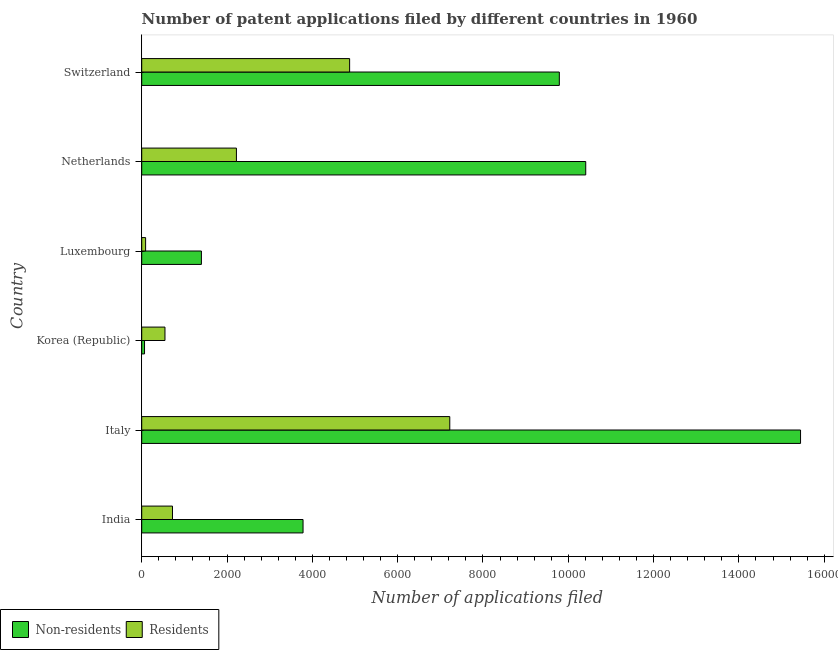Are the number of bars per tick equal to the number of legend labels?
Your answer should be very brief. Yes. How many bars are there on the 6th tick from the top?
Your answer should be compact. 2. What is the label of the 1st group of bars from the top?
Make the answer very short. Switzerland. In how many cases, is the number of bars for a given country not equal to the number of legend labels?
Offer a very short reply. 0. What is the number of patent applications by non residents in Luxembourg?
Your answer should be compact. 1399. Across all countries, what is the maximum number of patent applications by residents?
Keep it short and to the point. 7222. Across all countries, what is the minimum number of patent applications by non residents?
Your response must be concise. 66. What is the total number of patent applications by non residents in the graph?
Your answer should be compact. 4.09e+04. What is the difference between the number of patent applications by residents in Italy and that in Netherlands?
Your answer should be compact. 5002. What is the difference between the number of patent applications by non residents in Netherlands and the number of patent applications by residents in Switzerland?
Ensure brevity in your answer.  5535. What is the average number of patent applications by non residents per country?
Offer a terse response. 6815.17. What is the difference between the number of patent applications by non residents and number of patent applications by residents in Korea (Republic)?
Keep it short and to the point. -479. What is the ratio of the number of patent applications by non residents in Italy to that in Netherlands?
Ensure brevity in your answer.  1.48. What is the difference between the highest and the second highest number of patent applications by residents?
Offer a terse response. 2348. What is the difference between the highest and the lowest number of patent applications by residents?
Keep it short and to the point. 7131. In how many countries, is the number of patent applications by non residents greater than the average number of patent applications by non residents taken over all countries?
Keep it short and to the point. 3. What does the 2nd bar from the top in India represents?
Your answer should be compact. Non-residents. What does the 2nd bar from the bottom in India represents?
Your answer should be compact. Residents. What is the difference between two consecutive major ticks on the X-axis?
Make the answer very short. 2000. Does the graph contain any zero values?
Your answer should be very brief. No. Does the graph contain grids?
Provide a short and direct response. No. How are the legend labels stacked?
Ensure brevity in your answer.  Horizontal. What is the title of the graph?
Ensure brevity in your answer.  Number of patent applications filed by different countries in 1960. Does "Investments" appear as one of the legend labels in the graph?
Provide a short and direct response. No. What is the label or title of the X-axis?
Keep it short and to the point. Number of applications filed. What is the Number of applications filed of Non-residents in India?
Your answer should be very brief. 3782. What is the Number of applications filed in Residents in India?
Offer a very short reply. 721. What is the Number of applications filed of Non-residents in Italy?
Your answer should be compact. 1.54e+04. What is the Number of applications filed in Residents in Italy?
Your answer should be very brief. 7222. What is the Number of applications filed in Non-residents in Korea (Republic)?
Keep it short and to the point. 66. What is the Number of applications filed in Residents in Korea (Republic)?
Provide a short and direct response. 545. What is the Number of applications filed in Non-residents in Luxembourg?
Provide a succinct answer. 1399. What is the Number of applications filed in Residents in Luxembourg?
Keep it short and to the point. 91. What is the Number of applications filed in Non-residents in Netherlands?
Your response must be concise. 1.04e+04. What is the Number of applications filed of Residents in Netherlands?
Provide a short and direct response. 2220. What is the Number of applications filed in Non-residents in Switzerland?
Give a very brief answer. 9790. What is the Number of applications filed of Residents in Switzerland?
Provide a succinct answer. 4874. Across all countries, what is the maximum Number of applications filed in Non-residents?
Offer a terse response. 1.54e+04. Across all countries, what is the maximum Number of applications filed of Residents?
Provide a short and direct response. 7222. Across all countries, what is the minimum Number of applications filed in Residents?
Provide a short and direct response. 91. What is the total Number of applications filed of Non-residents in the graph?
Offer a terse response. 4.09e+04. What is the total Number of applications filed in Residents in the graph?
Provide a succinct answer. 1.57e+04. What is the difference between the Number of applications filed of Non-residents in India and that in Italy?
Offer a terse response. -1.17e+04. What is the difference between the Number of applications filed in Residents in India and that in Italy?
Keep it short and to the point. -6501. What is the difference between the Number of applications filed in Non-residents in India and that in Korea (Republic)?
Offer a very short reply. 3716. What is the difference between the Number of applications filed in Residents in India and that in Korea (Republic)?
Offer a very short reply. 176. What is the difference between the Number of applications filed of Non-residents in India and that in Luxembourg?
Ensure brevity in your answer.  2383. What is the difference between the Number of applications filed of Residents in India and that in Luxembourg?
Make the answer very short. 630. What is the difference between the Number of applications filed of Non-residents in India and that in Netherlands?
Keep it short and to the point. -6627. What is the difference between the Number of applications filed in Residents in India and that in Netherlands?
Provide a succinct answer. -1499. What is the difference between the Number of applications filed in Non-residents in India and that in Switzerland?
Offer a very short reply. -6008. What is the difference between the Number of applications filed in Residents in India and that in Switzerland?
Ensure brevity in your answer.  -4153. What is the difference between the Number of applications filed in Non-residents in Italy and that in Korea (Republic)?
Offer a very short reply. 1.54e+04. What is the difference between the Number of applications filed in Residents in Italy and that in Korea (Republic)?
Provide a short and direct response. 6677. What is the difference between the Number of applications filed in Non-residents in Italy and that in Luxembourg?
Provide a short and direct response. 1.40e+04. What is the difference between the Number of applications filed in Residents in Italy and that in Luxembourg?
Provide a succinct answer. 7131. What is the difference between the Number of applications filed in Non-residents in Italy and that in Netherlands?
Ensure brevity in your answer.  5036. What is the difference between the Number of applications filed in Residents in Italy and that in Netherlands?
Keep it short and to the point. 5002. What is the difference between the Number of applications filed of Non-residents in Italy and that in Switzerland?
Give a very brief answer. 5655. What is the difference between the Number of applications filed of Residents in Italy and that in Switzerland?
Keep it short and to the point. 2348. What is the difference between the Number of applications filed in Non-residents in Korea (Republic) and that in Luxembourg?
Your answer should be compact. -1333. What is the difference between the Number of applications filed in Residents in Korea (Republic) and that in Luxembourg?
Your answer should be compact. 454. What is the difference between the Number of applications filed of Non-residents in Korea (Republic) and that in Netherlands?
Provide a short and direct response. -1.03e+04. What is the difference between the Number of applications filed of Residents in Korea (Republic) and that in Netherlands?
Offer a terse response. -1675. What is the difference between the Number of applications filed in Non-residents in Korea (Republic) and that in Switzerland?
Give a very brief answer. -9724. What is the difference between the Number of applications filed of Residents in Korea (Republic) and that in Switzerland?
Your answer should be very brief. -4329. What is the difference between the Number of applications filed of Non-residents in Luxembourg and that in Netherlands?
Give a very brief answer. -9010. What is the difference between the Number of applications filed in Residents in Luxembourg and that in Netherlands?
Your answer should be very brief. -2129. What is the difference between the Number of applications filed of Non-residents in Luxembourg and that in Switzerland?
Your answer should be compact. -8391. What is the difference between the Number of applications filed of Residents in Luxembourg and that in Switzerland?
Offer a very short reply. -4783. What is the difference between the Number of applications filed in Non-residents in Netherlands and that in Switzerland?
Make the answer very short. 619. What is the difference between the Number of applications filed in Residents in Netherlands and that in Switzerland?
Offer a terse response. -2654. What is the difference between the Number of applications filed of Non-residents in India and the Number of applications filed of Residents in Italy?
Your response must be concise. -3440. What is the difference between the Number of applications filed in Non-residents in India and the Number of applications filed in Residents in Korea (Republic)?
Your answer should be compact. 3237. What is the difference between the Number of applications filed in Non-residents in India and the Number of applications filed in Residents in Luxembourg?
Give a very brief answer. 3691. What is the difference between the Number of applications filed in Non-residents in India and the Number of applications filed in Residents in Netherlands?
Keep it short and to the point. 1562. What is the difference between the Number of applications filed in Non-residents in India and the Number of applications filed in Residents in Switzerland?
Offer a terse response. -1092. What is the difference between the Number of applications filed of Non-residents in Italy and the Number of applications filed of Residents in Korea (Republic)?
Offer a very short reply. 1.49e+04. What is the difference between the Number of applications filed in Non-residents in Italy and the Number of applications filed in Residents in Luxembourg?
Your response must be concise. 1.54e+04. What is the difference between the Number of applications filed of Non-residents in Italy and the Number of applications filed of Residents in Netherlands?
Your answer should be very brief. 1.32e+04. What is the difference between the Number of applications filed in Non-residents in Italy and the Number of applications filed in Residents in Switzerland?
Provide a short and direct response. 1.06e+04. What is the difference between the Number of applications filed in Non-residents in Korea (Republic) and the Number of applications filed in Residents in Luxembourg?
Your answer should be compact. -25. What is the difference between the Number of applications filed of Non-residents in Korea (Republic) and the Number of applications filed of Residents in Netherlands?
Your answer should be very brief. -2154. What is the difference between the Number of applications filed in Non-residents in Korea (Republic) and the Number of applications filed in Residents in Switzerland?
Keep it short and to the point. -4808. What is the difference between the Number of applications filed in Non-residents in Luxembourg and the Number of applications filed in Residents in Netherlands?
Ensure brevity in your answer.  -821. What is the difference between the Number of applications filed of Non-residents in Luxembourg and the Number of applications filed of Residents in Switzerland?
Offer a terse response. -3475. What is the difference between the Number of applications filed of Non-residents in Netherlands and the Number of applications filed of Residents in Switzerland?
Your response must be concise. 5535. What is the average Number of applications filed in Non-residents per country?
Your response must be concise. 6815.17. What is the average Number of applications filed of Residents per country?
Offer a terse response. 2612.17. What is the difference between the Number of applications filed of Non-residents and Number of applications filed of Residents in India?
Give a very brief answer. 3061. What is the difference between the Number of applications filed in Non-residents and Number of applications filed in Residents in Italy?
Make the answer very short. 8223. What is the difference between the Number of applications filed in Non-residents and Number of applications filed in Residents in Korea (Republic)?
Provide a succinct answer. -479. What is the difference between the Number of applications filed in Non-residents and Number of applications filed in Residents in Luxembourg?
Offer a very short reply. 1308. What is the difference between the Number of applications filed in Non-residents and Number of applications filed in Residents in Netherlands?
Keep it short and to the point. 8189. What is the difference between the Number of applications filed in Non-residents and Number of applications filed in Residents in Switzerland?
Your answer should be compact. 4916. What is the ratio of the Number of applications filed of Non-residents in India to that in Italy?
Offer a very short reply. 0.24. What is the ratio of the Number of applications filed in Residents in India to that in Italy?
Provide a succinct answer. 0.1. What is the ratio of the Number of applications filed in Non-residents in India to that in Korea (Republic)?
Provide a succinct answer. 57.3. What is the ratio of the Number of applications filed of Residents in India to that in Korea (Republic)?
Provide a succinct answer. 1.32. What is the ratio of the Number of applications filed in Non-residents in India to that in Luxembourg?
Your response must be concise. 2.7. What is the ratio of the Number of applications filed in Residents in India to that in Luxembourg?
Ensure brevity in your answer.  7.92. What is the ratio of the Number of applications filed in Non-residents in India to that in Netherlands?
Your answer should be compact. 0.36. What is the ratio of the Number of applications filed in Residents in India to that in Netherlands?
Provide a short and direct response. 0.32. What is the ratio of the Number of applications filed in Non-residents in India to that in Switzerland?
Your answer should be compact. 0.39. What is the ratio of the Number of applications filed in Residents in India to that in Switzerland?
Provide a succinct answer. 0.15. What is the ratio of the Number of applications filed of Non-residents in Italy to that in Korea (Republic)?
Ensure brevity in your answer.  234.02. What is the ratio of the Number of applications filed of Residents in Italy to that in Korea (Republic)?
Keep it short and to the point. 13.25. What is the ratio of the Number of applications filed in Non-residents in Italy to that in Luxembourg?
Your response must be concise. 11.04. What is the ratio of the Number of applications filed in Residents in Italy to that in Luxembourg?
Give a very brief answer. 79.36. What is the ratio of the Number of applications filed in Non-residents in Italy to that in Netherlands?
Give a very brief answer. 1.48. What is the ratio of the Number of applications filed in Residents in Italy to that in Netherlands?
Make the answer very short. 3.25. What is the ratio of the Number of applications filed in Non-residents in Italy to that in Switzerland?
Make the answer very short. 1.58. What is the ratio of the Number of applications filed in Residents in Italy to that in Switzerland?
Keep it short and to the point. 1.48. What is the ratio of the Number of applications filed of Non-residents in Korea (Republic) to that in Luxembourg?
Provide a succinct answer. 0.05. What is the ratio of the Number of applications filed in Residents in Korea (Republic) to that in Luxembourg?
Your answer should be compact. 5.99. What is the ratio of the Number of applications filed of Non-residents in Korea (Republic) to that in Netherlands?
Offer a very short reply. 0.01. What is the ratio of the Number of applications filed in Residents in Korea (Republic) to that in Netherlands?
Your answer should be very brief. 0.25. What is the ratio of the Number of applications filed of Non-residents in Korea (Republic) to that in Switzerland?
Keep it short and to the point. 0.01. What is the ratio of the Number of applications filed of Residents in Korea (Republic) to that in Switzerland?
Offer a terse response. 0.11. What is the ratio of the Number of applications filed of Non-residents in Luxembourg to that in Netherlands?
Make the answer very short. 0.13. What is the ratio of the Number of applications filed of Residents in Luxembourg to that in Netherlands?
Offer a very short reply. 0.04. What is the ratio of the Number of applications filed of Non-residents in Luxembourg to that in Switzerland?
Your answer should be very brief. 0.14. What is the ratio of the Number of applications filed in Residents in Luxembourg to that in Switzerland?
Make the answer very short. 0.02. What is the ratio of the Number of applications filed of Non-residents in Netherlands to that in Switzerland?
Keep it short and to the point. 1.06. What is the ratio of the Number of applications filed of Residents in Netherlands to that in Switzerland?
Provide a succinct answer. 0.46. What is the difference between the highest and the second highest Number of applications filed of Non-residents?
Your answer should be very brief. 5036. What is the difference between the highest and the second highest Number of applications filed of Residents?
Give a very brief answer. 2348. What is the difference between the highest and the lowest Number of applications filed of Non-residents?
Your answer should be compact. 1.54e+04. What is the difference between the highest and the lowest Number of applications filed of Residents?
Give a very brief answer. 7131. 